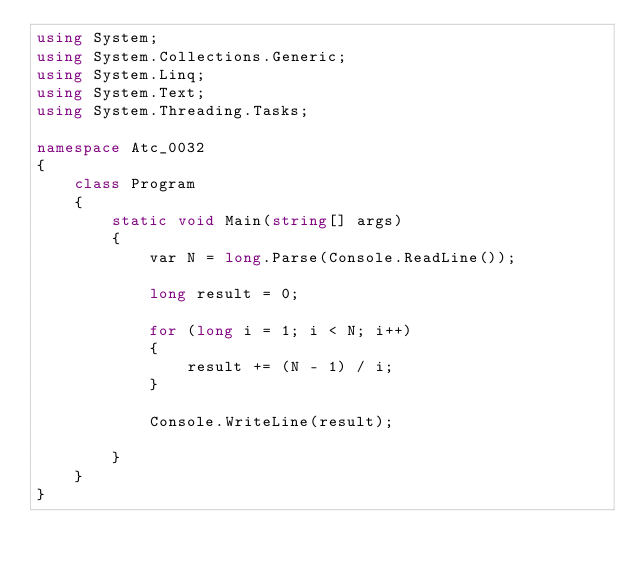Convert code to text. <code><loc_0><loc_0><loc_500><loc_500><_C#_>using System;
using System.Collections.Generic;
using System.Linq;
using System.Text;
using System.Threading.Tasks;

namespace Atc_0032
{
    class Program
    {
        static void Main(string[] args)
        {
            var N = long.Parse(Console.ReadLine());

            long result = 0;

            for (long i = 1; i < N; i++)
            {
                result += (N - 1) / i;
            }

            Console.WriteLine(result);

        }
    }
}</code> 